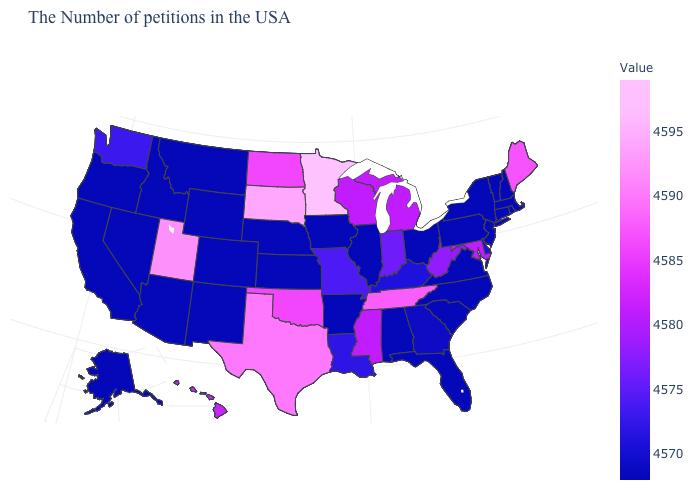Among the states that border New Jersey , which have the highest value?
Keep it brief. Delaware. Among the states that border Washington , which have the highest value?
Short answer required. Idaho, Oregon. Is the legend a continuous bar?
Answer briefly. Yes. Does Massachusetts have the highest value in the Northeast?
Quick response, please. No. Among the states that border Maine , which have the highest value?
Keep it brief. New Hampshire. 